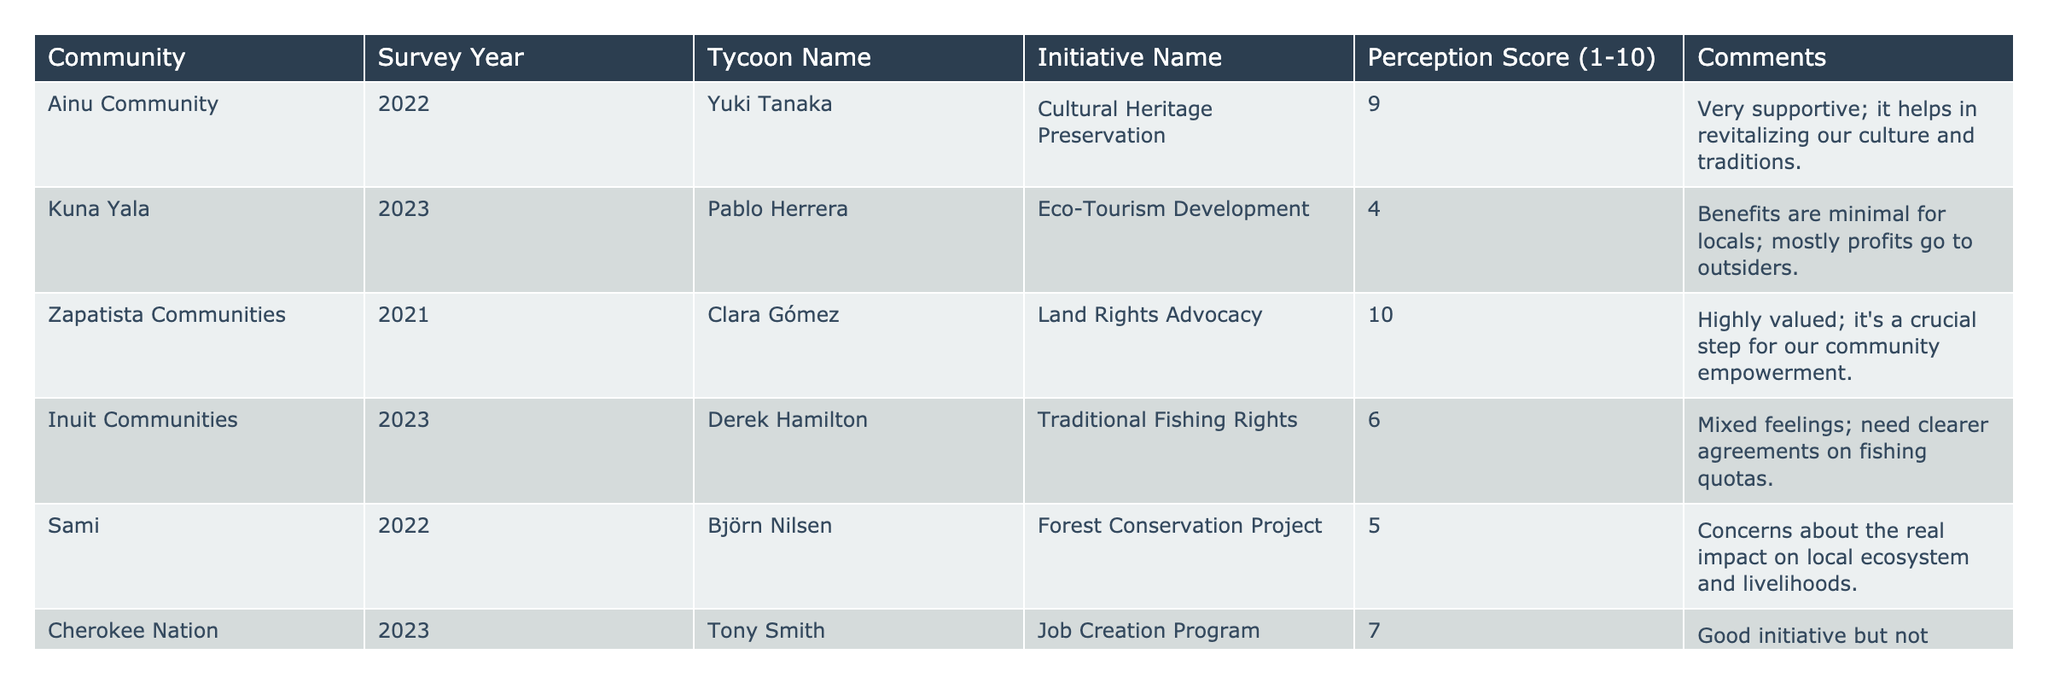What's the highest perception score in the table? The highest perception score listed in the table is 10, which is found in the Zapatista Communities row for the initiative on Land Rights Advocacy.
Answer: 10 Which tycoon has the lowest perception score for their initiative? Pablo Herrera has the lowest perception score of 4 for the Eco-Tourism Development initiative in Kuna Yala.
Answer: Pablo Herrera What initiatives have a perception score of 6 or higher? The initiatives with a perception score of 6 or higher are Cultural Heritage Preservation (9), Land Rights Advocacy (10), Traditional Fishing Rights (6), and Job Creation Program (7).
Answer: Cultural Heritage Preservation, Land Rights Advocacy, Traditional Fishing Rights, Job Creation Program What is the average perception score for all initiatives in the table? To find the average, we sum the perception scores: 9 + 4 + 10 + 6 + 5 + 7 = 41. There are 6 initiatives, so the average score is 41/6 = 6.833.
Answer: 6.83 Is the perception score for the Forest Conservation Project greater than 6? The perception score for the Forest Conservation Project is 5, which is not greater than 6. Therefore, the answer is no.
Answer: No Which community values land rights advocacy the most based on perception score? The Zapatista Communities value the Land Rights Advocacy initiative the most, with the highest perception score of 10.
Answer: Zapatista Communities How many initiatives have a perception score lower than 6? There are two initiatives with a perception score lower than 6: Eco-Tourism Development (4) and Forest Conservation Project (5).
Answer: 2 What is the perception score difference between the highest and lowest scoring initiatives? The highest score is 10 (Land Rights Advocacy) and the lowest score is 4 (Eco-Tourism Development). The difference is 10 - 4 = 6.
Answer: 6 Which community showed mixed feelings about their initiative? The Inuit Communities expressed mixed feelings about the Traditional Fishing Rights initiative, reflected in their perception score of 6.
Answer: Inuit Communities Are there any initiatives that received a perception score of 5? Yes, the Forest Conservation Project received a perception score of 5, indicating a neutral or average perception.
Answer: Yes 